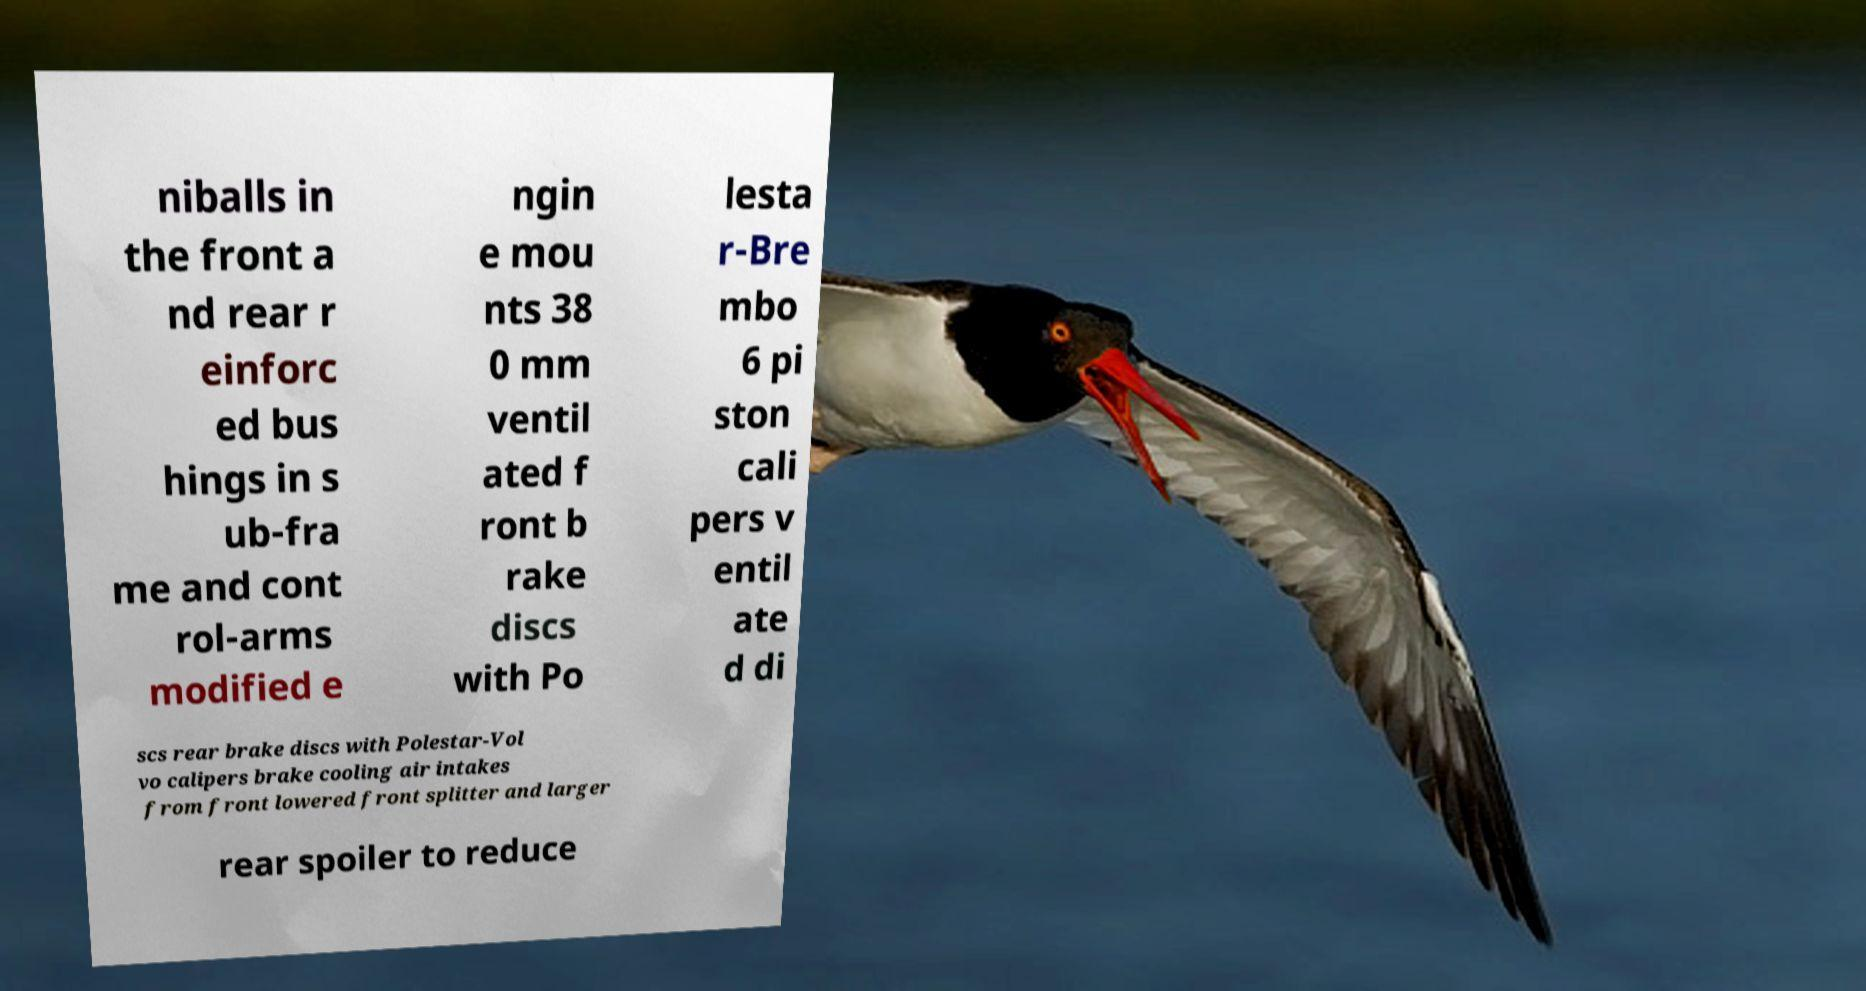Could you assist in decoding the text presented in this image and type it out clearly? niballs in the front a nd rear r einforc ed bus hings in s ub-fra me and cont rol-arms modified e ngin e mou nts 38 0 mm ventil ated f ront b rake discs with Po lesta r-Bre mbo 6 pi ston cali pers v entil ate d di scs rear brake discs with Polestar-Vol vo calipers brake cooling air intakes from front lowered front splitter and larger rear spoiler to reduce 